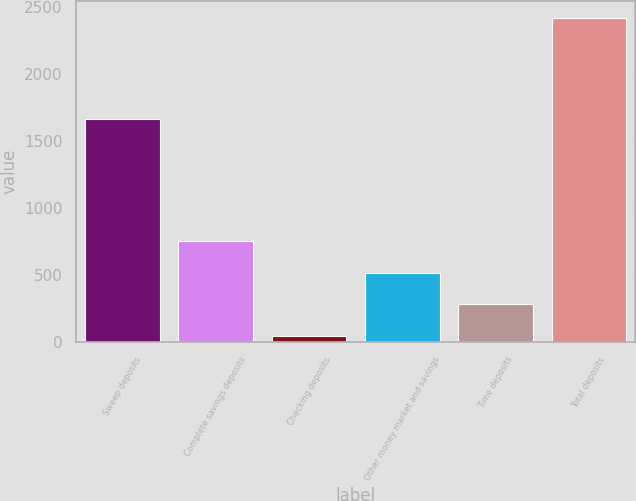Convert chart. <chart><loc_0><loc_0><loc_500><loc_500><bar_chart><fcel>Sweep deposits<fcel>Complete savings deposits<fcel>Checking deposits<fcel>Other money market and savings<fcel>Time deposits<fcel>Total deposits<nl><fcel>1661.5<fcel>756.3<fcel>42.6<fcel>518.4<fcel>280.5<fcel>2421.6<nl></chart> 